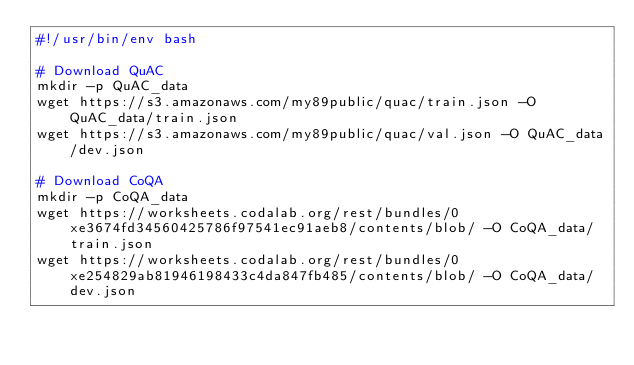<code> <loc_0><loc_0><loc_500><loc_500><_Bash_>#!/usr/bin/env bash

# Download QuAC
mkdir -p QuAC_data
wget https://s3.amazonaws.com/my89public/quac/train.json -O QuAC_data/train.json
wget https://s3.amazonaws.com/my89public/quac/val.json -O QuAC_data/dev.json

# Download CoQA
mkdir -p CoQA_data
wget https://worksheets.codalab.org/rest/bundles/0xe3674fd34560425786f97541ec91aeb8/contents/blob/ -O CoQA_data/train.json
wget https://worksheets.codalab.org/rest/bundles/0xe254829ab81946198433c4da847fb485/contents/blob/ -O CoQA_data/dev.json

</code> 